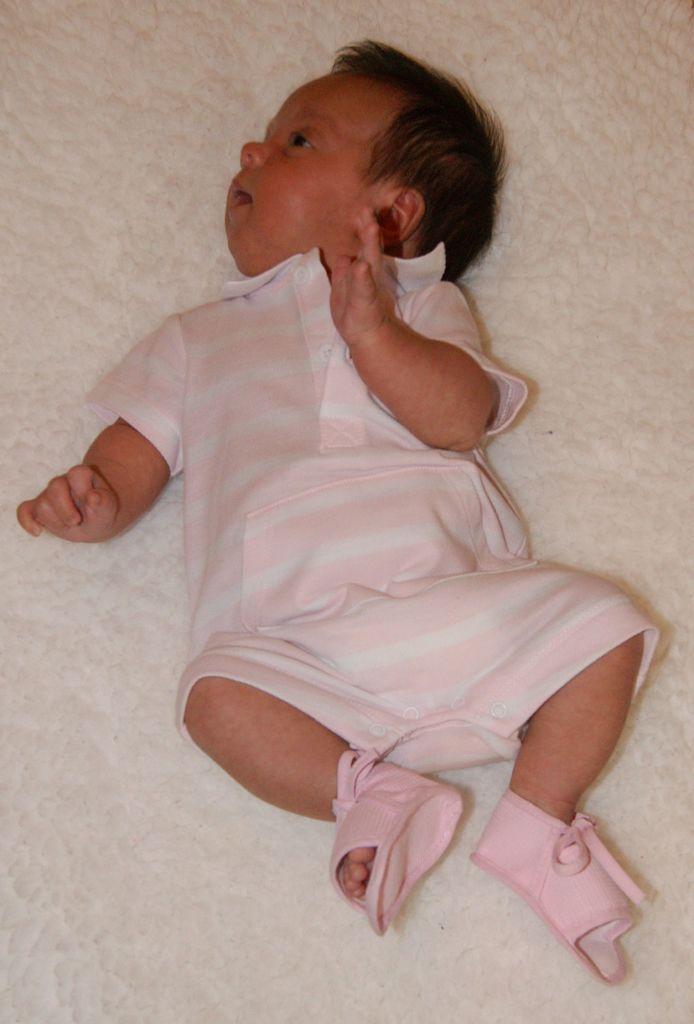How would you summarize this image in a sentence or two? In this picture we can see a baby is lying on mattress. 